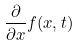<formula> <loc_0><loc_0><loc_500><loc_500>\frac { \partial } { \partial x } f ( x , t )</formula> 